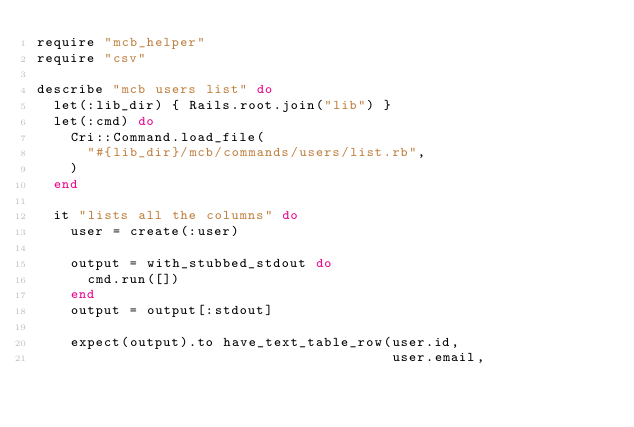<code> <loc_0><loc_0><loc_500><loc_500><_Ruby_>require "mcb_helper"
require "csv"

describe "mcb users list" do
  let(:lib_dir) { Rails.root.join("lib") }
  let(:cmd) do
    Cri::Command.load_file(
      "#{lib_dir}/mcb/commands/users/list.rb",
    )
  end

  it "lists all the columns" do
    user = create(:user)

    output = with_stubbed_stdout do
      cmd.run([])
    end
    output = output[:stdout]

    expect(output).to have_text_table_row(user.id,
                                          user.email,</code> 